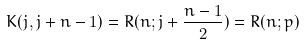Convert formula to latex. <formula><loc_0><loc_0><loc_500><loc_500>K ( j , j + n - 1 ) = R ( n ; j + \frac { n - 1 } { 2 } ) = R ( n ; p )</formula> 